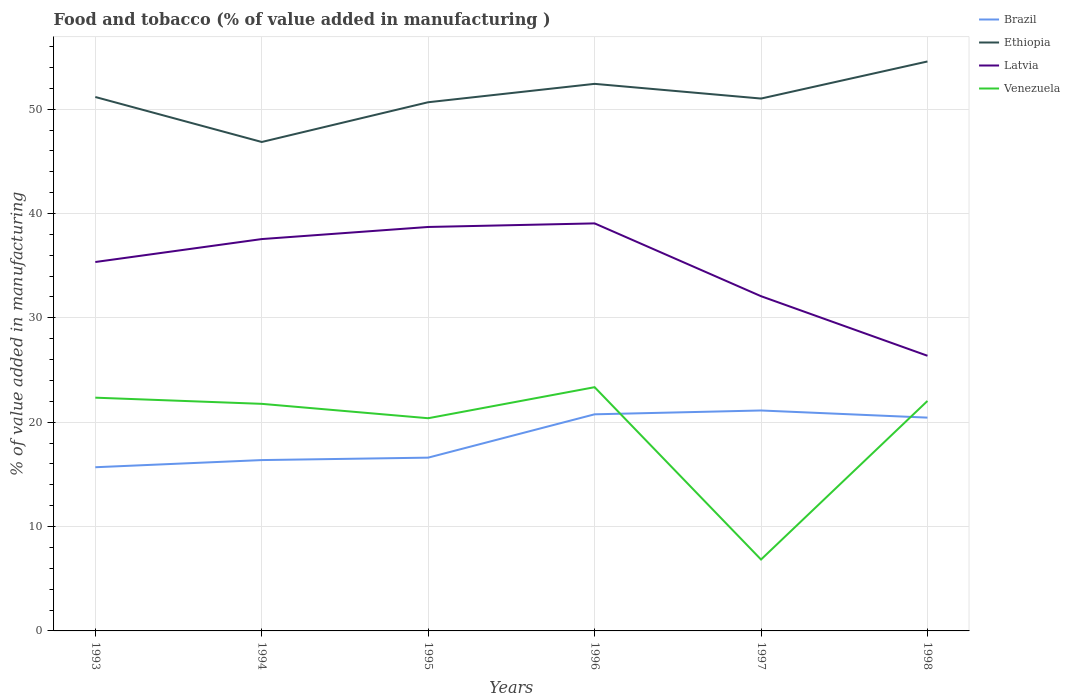How many different coloured lines are there?
Offer a terse response. 4. Does the line corresponding to Venezuela intersect with the line corresponding to Ethiopia?
Make the answer very short. No. Across all years, what is the maximum value added in manufacturing food and tobacco in Venezuela?
Give a very brief answer. 6.84. In which year was the value added in manufacturing food and tobacco in Ethiopia maximum?
Offer a terse response. 1994. What is the total value added in manufacturing food and tobacco in Latvia in the graph?
Ensure brevity in your answer.  12.34. What is the difference between the highest and the second highest value added in manufacturing food and tobacco in Ethiopia?
Your response must be concise. 7.71. What is the difference between two consecutive major ticks on the Y-axis?
Provide a short and direct response. 10. Does the graph contain any zero values?
Ensure brevity in your answer.  No. Where does the legend appear in the graph?
Offer a very short reply. Top right. What is the title of the graph?
Offer a terse response. Food and tobacco (% of value added in manufacturing ). Does "Panama" appear as one of the legend labels in the graph?
Provide a succinct answer. No. What is the label or title of the X-axis?
Keep it short and to the point. Years. What is the label or title of the Y-axis?
Offer a very short reply. % of value added in manufacturing. What is the % of value added in manufacturing in Brazil in 1993?
Offer a terse response. 15.69. What is the % of value added in manufacturing of Ethiopia in 1993?
Offer a terse response. 51.16. What is the % of value added in manufacturing in Latvia in 1993?
Your answer should be compact. 35.35. What is the % of value added in manufacturing of Venezuela in 1993?
Your response must be concise. 22.35. What is the % of value added in manufacturing of Brazil in 1994?
Your answer should be compact. 16.37. What is the % of value added in manufacturing of Ethiopia in 1994?
Offer a very short reply. 46.85. What is the % of value added in manufacturing of Latvia in 1994?
Offer a very short reply. 37.55. What is the % of value added in manufacturing of Venezuela in 1994?
Provide a succinct answer. 21.76. What is the % of value added in manufacturing in Brazil in 1995?
Ensure brevity in your answer.  16.6. What is the % of value added in manufacturing in Ethiopia in 1995?
Provide a succinct answer. 50.66. What is the % of value added in manufacturing of Latvia in 1995?
Give a very brief answer. 38.71. What is the % of value added in manufacturing of Venezuela in 1995?
Give a very brief answer. 20.38. What is the % of value added in manufacturing in Brazil in 1996?
Make the answer very short. 20.76. What is the % of value added in manufacturing in Ethiopia in 1996?
Provide a short and direct response. 52.42. What is the % of value added in manufacturing of Latvia in 1996?
Your response must be concise. 39.05. What is the % of value added in manufacturing in Venezuela in 1996?
Give a very brief answer. 23.36. What is the % of value added in manufacturing of Brazil in 1997?
Make the answer very short. 21.12. What is the % of value added in manufacturing in Ethiopia in 1997?
Provide a short and direct response. 51.01. What is the % of value added in manufacturing in Latvia in 1997?
Give a very brief answer. 32.08. What is the % of value added in manufacturing of Venezuela in 1997?
Give a very brief answer. 6.84. What is the % of value added in manufacturing of Brazil in 1998?
Your response must be concise. 20.44. What is the % of value added in manufacturing in Ethiopia in 1998?
Make the answer very short. 54.57. What is the % of value added in manufacturing of Latvia in 1998?
Make the answer very short. 26.37. What is the % of value added in manufacturing in Venezuela in 1998?
Offer a very short reply. 22.04. Across all years, what is the maximum % of value added in manufacturing of Brazil?
Give a very brief answer. 21.12. Across all years, what is the maximum % of value added in manufacturing in Ethiopia?
Make the answer very short. 54.57. Across all years, what is the maximum % of value added in manufacturing in Latvia?
Offer a very short reply. 39.05. Across all years, what is the maximum % of value added in manufacturing in Venezuela?
Provide a succinct answer. 23.36. Across all years, what is the minimum % of value added in manufacturing in Brazil?
Keep it short and to the point. 15.69. Across all years, what is the minimum % of value added in manufacturing in Ethiopia?
Keep it short and to the point. 46.85. Across all years, what is the minimum % of value added in manufacturing in Latvia?
Offer a very short reply. 26.37. Across all years, what is the minimum % of value added in manufacturing of Venezuela?
Ensure brevity in your answer.  6.84. What is the total % of value added in manufacturing of Brazil in the graph?
Your answer should be very brief. 110.98. What is the total % of value added in manufacturing in Ethiopia in the graph?
Keep it short and to the point. 306.68. What is the total % of value added in manufacturing of Latvia in the graph?
Provide a short and direct response. 209.1. What is the total % of value added in manufacturing in Venezuela in the graph?
Provide a short and direct response. 116.72. What is the difference between the % of value added in manufacturing of Brazil in 1993 and that in 1994?
Offer a terse response. -0.69. What is the difference between the % of value added in manufacturing of Ethiopia in 1993 and that in 1994?
Provide a succinct answer. 4.31. What is the difference between the % of value added in manufacturing in Latvia in 1993 and that in 1994?
Your answer should be compact. -2.2. What is the difference between the % of value added in manufacturing of Venezuela in 1993 and that in 1994?
Provide a short and direct response. 0.59. What is the difference between the % of value added in manufacturing in Brazil in 1993 and that in 1995?
Provide a succinct answer. -0.92. What is the difference between the % of value added in manufacturing of Ethiopia in 1993 and that in 1995?
Provide a succinct answer. 0.5. What is the difference between the % of value added in manufacturing of Latvia in 1993 and that in 1995?
Offer a very short reply. -3.36. What is the difference between the % of value added in manufacturing in Venezuela in 1993 and that in 1995?
Keep it short and to the point. 1.97. What is the difference between the % of value added in manufacturing in Brazil in 1993 and that in 1996?
Your answer should be very brief. -5.07. What is the difference between the % of value added in manufacturing of Ethiopia in 1993 and that in 1996?
Offer a very short reply. -1.26. What is the difference between the % of value added in manufacturing of Latvia in 1993 and that in 1996?
Your answer should be compact. -3.7. What is the difference between the % of value added in manufacturing in Venezuela in 1993 and that in 1996?
Your answer should be very brief. -1.01. What is the difference between the % of value added in manufacturing in Brazil in 1993 and that in 1997?
Your response must be concise. -5.44. What is the difference between the % of value added in manufacturing in Ethiopia in 1993 and that in 1997?
Offer a very short reply. 0.15. What is the difference between the % of value added in manufacturing of Latvia in 1993 and that in 1997?
Keep it short and to the point. 3.28. What is the difference between the % of value added in manufacturing of Venezuela in 1993 and that in 1997?
Offer a very short reply. 15.51. What is the difference between the % of value added in manufacturing in Brazil in 1993 and that in 1998?
Provide a succinct answer. -4.75. What is the difference between the % of value added in manufacturing of Ethiopia in 1993 and that in 1998?
Your answer should be very brief. -3.4. What is the difference between the % of value added in manufacturing of Latvia in 1993 and that in 1998?
Your response must be concise. 8.98. What is the difference between the % of value added in manufacturing of Venezuela in 1993 and that in 1998?
Your response must be concise. 0.31. What is the difference between the % of value added in manufacturing of Brazil in 1994 and that in 1995?
Offer a terse response. -0.23. What is the difference between the % of value added in manufacturing of Ethiopia in 1994 and that in 1995?
Your answer should be compact. -3.81. What is the difference between the % of value added in manufacturing in Latvia in 1994 and that in 1995?
Ensure brevity in your answer.  -1.16. What is the difference between the % of value added in manufacturing of Venezuela in 1994 and that in 1995?
Ensure brevity in your answer.  1.38. What is the difference between the % of value added in manufacturing of Brazil in 1994 and that in 1996?
Your response must be concise. -4.39. What is the difference between the % of value added in manufacturing in Ethiopia in 1994 and that in 1996?
Offer a terse response. -5.57. What is the difference between the % of value added in manufacturing of Latvia in 1994 and that in 1996?
Offer a terse response. -1.5. What is the difference between the % of value added in manufacturing of Venezuela in 1994 and that in 1996?
Make the answer very short. -1.6. What is the difference between the % of value added in manufacturing of Brazil in 1994 and that in 1997?
Give a very brief answer. -4.75. What is the difference between the % of value added in manufacturing in Ethiopia in 1994 and that in 1997?
Make the answer very short. -4.16. What is the difference between the % of value added in manufacturing of Latvia in 1994 and that in 1997?
Offer a very short reply. 5.47. What is the difference between the % of value added in manufacturing of Venezuela in 1994 and that in 1997?
Keep it short and to the point. 14.92. What is the difference between the % of value added in manufacturing of Brazil in 1994 and that in 1998?
Ensure brevity in your answer.  -4.07. What is the difference between the % of value added in manufacturing of Ethiopia in 1994 and that in 1998?
Keep it short and to the point. -7.71. What is the difference between the % of value added in manufacturing in Latvia in 1994 and that in 1998?
Offer a terse response. 11.18. What is the difference between the % of value added in manufacturing of Venezuela in 1994 and that in 1998?
Ensure brevity in your answer.  -0.28. What is the difference between the % of value added in manufacturing of Brazil in 1995 and that in 1996?
Provide a short and direct response. -4.15. What is the difference between the % of value added in manufacturing of Ethiopia in 1995 and that in 1996?
Your response must be concise. -1.76. What is the difference between the % of value added in manufacturing of Latvia in 1995 and that in 1996?
Provide a succinct answer. -0.34. What is the difference between the % of value added in manufacturing of Venezuela in 1995 and that in 1996?
Give a very brief answer. -2.98. What is the difference between the % of value added in manufacturing of Brazil in 1995 and that in 1997?
Give a very brief answer. -4.52. What is the difference between the % of value added in manufacturing in Ethiopia in 1995 and that in 1997?
Your answer should be compact. -0.35. What is the difference between the % of value added in manufacturing of Latvia in 1995 and that in 1997?
Your answer should be very brief. 6.63. What is the difference between the % of value added in manufacturing in Venezuela in 1995 and that in 1997?
Your response must be concise. 13.54. What is the difference between the % of value added in manufacturing of Brazil in 1995 and that in 1998?
Ensure brevity in your answer.  -3.83. What is the difference between the % of value added in manufacturing of Ethiopia in 1995 and that in 1998?
Make the answer very short. -3.91. What is the difference between the % of value added in manufacturing in Latvia in 1995 and that in 1998?
Offer a terse response. 12.34. What is the difference between the % of value added in manufacturing of Venezuela in 1995 and that in 1998?
Your answer should be very brief. -1.66. What is the difference between the % of value added in manufacturing of Brazil in 1996 and that in 1997?
Ensure brevity in your answer.  -0.37. What is the difference between the % of value added in manufacturing in Ethiopia in 1996 and that in 1997?
Ensure brevity in your answer.  1.41. What is the difference between the % of value added in manufacturing in Latvia in 1996 and that in 1997?
Keep it short and to the point. 6.98. What is the difference between the % of value added in manufacturing of Venezuela in 1996 and that in 1997?
Provide a succinct answer. 16.51. What is the difference between the % of value added in manufacturing in Brazil in 1996 and that in 1998?
Keep it short and to the point. 0.32. What is the difference between the % of value added in manufacturing in Ethiopia in 1996 and that in 1998?
Your answer should be very brief. -2.14. What is the difference between the % of value added in manufacturing of Latvia in 1996 and that in 1998?
Ensure brevity in your answer.  12.68. What is the difference between the % of value added in manufacturing in Venezuela in 1996 and that in 1998?
Ensure brevity in your answer.  1.32. What is the difference between the % of value added in manufacturing of Brazil in 1997 and that in 1998?
Provide a succinct answer. 0.68. What is the difference between the % of value added in manufacturing of Ethiopia in 1997 and that in 1998?
Your response must be concise. -3.55. What is the difference between the % of value added in manufacturing of Latvia in 1997 and that in 1998?
Offer a terse response. 5.71. What is the difference between the % of value added in manufacturing of Venezuela in 1997 and that in 1998?
Make the answer very short. -15.2. What is the difference between the % of value added in manufacturing of Brazil in 1993 and the % of value added in manufacturing of Ethiopia in 1994?
Your answer should be compact. -31.17. What is the difference between the % of value added in manufacturing in Brazil in 1993 and the % of value added in manufacturing in Latvia in 1994?
Ensure brevity in your answer.  -21.86. What is the difference between the % of value added in manufacturing in Brazil in 1993 and the % of value added in manufacturing in Venezuela in 1994?
Ensure brevity in your answer.  -6.07. What is the difference between the % of value added in manufacturing in Ethiopia in 1993 and the % of value added in manufacturing in Latvia in 1994?
Provide a succinct answer. 13.61. What is the difference between the % of value added in manufacturing in Ethiopia in 1993 and the % of value added in manufacturing in Venezuela in 1994?
Provide a succinct answer. 29.4. What is the difference between the % of value added in manufacturing in Latvia in 1993 and the % of value added in manufacturing in Venezuela in 1994?
Offer a very short reply. 13.59. What is the difference between the % of value added in manufacturing of Brazil in 1993 and the % of value added in manufacturing of Ethiopia in 1995?
Offer a terse response. -34.98. What is the difference between the % of value added in manufacturing of Brazil in 1993 and the % of value added in manufacturing of Latvia in 1995?
Provide a short and direct response. -23.02. What is the difference between the % of value added in manufacturing of Brazil in 1993 and the % of value added in manufacturing of Venezuela in 1995?
Make the answer very short. -4.7. What is the difference between the % of value added in manufacturing in Ethiopia in 1993 and the % of value added in manufacturing in Latvia in 1995?
Provide a succinct answer. 12.46. What is the difference between the % of value added in manufacturing in Ethiopia in 1993 and the % of value added in manufacturing in Venezuela in 1995?
Keep it short and to the point. 30.78. What is the difference between the % of value added in manufacturing of Latvia in 1993 and the % of value added in manufacturing of Venezuela in 1995?
Make the answer very short. 14.97. What is the difference between the % of value added in manufacturing of Brazil in 1993 and the % of value added in manufacturing of Ethiopia in 1996?
Make the answer very short. -36.74. What is the difference between the % of value added in manufacturing of Brazil in 1993 and the % of value added in manufacturing of Latvia in 1996?
Ensure brevity in your answer.  -23.37. What is the difference between the % of value added in manufacturing in Brazil in 1993 and the % of value added in manufacturing in Venezuela in 1996?
Your answer should be very brief. -7.67. What is the difference between the % of value added in manufacturing in Ethiopia in 1993 and the % of value added in manufacturing in Latvia in 1996?
Provide a succinct answer. 12.11. What is the difference between the % of value added in manufacturing in Ethiopia in 1993 and the % of value added in manufacturing in Venezuela in 1996?
Provide a succinct answer. 27.81. What is the difference between the % of value added in manufacturing of Latvia in 1993 and the % of value added in manufacturing of Venezuela in 1996?
Your answer should be very brief. 11.99. What is the difference between the % of value added in manufacturing of Brazil in 1993 and the % of value added in manufacturing of Ethiopia in 1997?
Provide a succinct answer. -35.33. What is the difference between the % of value added in manufacturing in Brazil in 1993 and the % of value added in manufacturing in Latvia in 1997?
Ensure brevity in your answer.  -16.39. What is the difference between the % of value added in manufacturing in Brazil in 1993 and the % of value added in manufacturing in Venezuela in 1997?
Provide a succinct answer. 8.84. What is the difference between the % of value added in manufacturing of Ethiopia in 1993 and the % of value added in manufacturing of Latvia in 1997?
Your answer should be compact. 19.09. What is the difference between the % of value added in manufacturing in Ethiopia in 1993 and the % of value added in manufacturing in Venezuela in 1997?
Provide a succinct answer. 44.32. What is the difference between the % of value added in manufacturing in Latvia in 1993 and the % of value added in manufacturing in Venezuela in 1997?
Give a very brief answer. 28.51. What is the difference between the % of value added in manufacturing of Brazil in 1993 and the % of value added in manufacturing of Ethiopia in 1998?
Offer a terse response. -38.88. What is the difference between the % of value added in manufacturing in Brazil in 1993 and the % of value added in manufacturing in Latvia in 1998?
Your answer should be very brief. -10.68. What is the difference between the % of value added in manufacturing in Brazil in 1993 and the % of value added in manufacturing in Venezuela in 1998?
Your answer should be very brief. -6.35. What is the difference between the % of value added in manufacturing in Ethiopia in 1993 and the % of value added in manufacturing in Latvia in 1998?
Your response must be concise. 24.8. What is the difference between the % of value added in manufacturing of Ethiopia in 1993 and the % of value added in manufacturing of Venezuela in 1998?
Keep it short and to the point. 29.13. What is the difference between the % of value added in manufacturing of Latvia in 1993 and the % of value added in manufacturing of Venezuela in 1998?
Keep it short and to the point. 13.31. What is the difference between the % of value added in manufacturing of Brazil in 1994 and the % of value added in manufacturing of Ethiopia in 1995?
Offer a very short reply. -34.29. What is the difference between the % of value added in manufacturing of Brazil in 1994 and the % of value added in manufacturing of Latvia in 1995?
Offer a very short reply. -22.34. What is the difference between the % of value added in manufacturing of Brazil in 1994 and the % of value added in manufacturing of Venezuela in 1995?
Provide a succinct answer. -4.01. What is the difference between the % of value added in manufacturing of Ethiopia in 1994 and the % of value added in manufacturing of Latvia in 1995?
Your response must be concise. 8.14. What is the difference between the % of value added in manufacturing in Ethiopia in 1994 and the % of value added in manufacturing in Venezuela in 1995?
Offer a very short reply. 26.47. What is the difference between the % of value added in manufacturing in Latvia in 1994 and the % of value added in manufacturing in Venezuela in 1995?
Make the answer very short. 17.17. What is the difference between the % of value added in manufacturing of Brazil in 1994 and the % of value added in manufacturing of Ethiopia in 1996?
Offer a very short reply. -36.05. What is the difference between the % of value added in manufacturing in Brazil in 1994 and the % of value added in manufacturing in Latvia in 1996?
Make the answer very short. -22.68. What is the difference between the % of value added in manufacturing of Brazil in 1994 and the % of value added in manufacturing of Venezuela in 1996?
Give a very brief answer. -6.99. What is the difference between the % of value added in manufacturing in Ethiopia in 1994 and the % of value added in manufacturing in Latvia in 1996?
Offer a terse response. 7.8. What is the difference between the % of value added in manufacturing in Ethiopia in 1994 and the % of value added in manufacturing in Venezuela in 1996?
Offer a very short reply. 23.5. What is the difference between the % of value added in manufacturing of Latvia in 1994 and the % of value added in manufacturing of Venezuela in 1996?
Your response must be concise. 14.19. What is the difference between the % of value added in manufacturing of Brazil in 1994 and the % of value added in manufacturing of Ethiopia in 1997?
Offer a terse response. -34.64. What is the difference between the % of value added in manufacturing in Brazil in 1994 and the % of value added in manufacturing in Latvia in 1997?
Give a very brief answer. -15.7. What is the difference between the % of value added in manufacturing of Brazil in 1994 and the % of value added in manufacturing of Venezuela in 1997?
Provide a short and direct response. 9.53. What is the difference between the % of value added in manufacturing in Ethiopia in 1994 and the % of value added in manufacturing in Latvia in 1997?
Make the answer very short. 14.78. What is the difference between the % of value added in manufacturing of Ethiopia in 1994 and the % of value added in manufacturing of Venezuela in 1997?
Your response must be concise. 40.01. What is the difference between the % of value added in manufacturing in Latvia in 1994 and the % of value added in manufacturing in Venezuela in 1997?
Provide a succinct answer. 30.71. What is the difference between the % of value added in manufacturing of Brazil in 1994 and the % of value added in manufacturing of Ethiopia in 1998?
Provide a succinct answer. -38.2. What is the difference between the % of value added in manufacturing of Brazil in 1994 and the % of value added in manufacturing of Latvia in 1998?
Your response must be concise. -10. What is the difference between the % of value added in manufacturing of Brazil in 1994 and the % of value added in manufacturing of Venezuela in 1998?
Your response must be concise. -5.67. What is the difference between the % of value added in manufacturing in Ethiopia in 1994 and the % of value added in manufacturing in Latvia in 1998?
Offer a very short reply. 20.48. What is the difference between the % of value added in manufacturing of Ethiopia in 1994 and the % of value added in manufacturing of Venezuela in 1998?
Provide a short and direct response. 24.82. What is the difference between the % of value added in manufacturing in Latvia in 1994 and the % of value added in manufacturing in Venezuela in 1998?
Offer a very short reply. 15.51. What is the difference between the % of value added in manufacturing in Brazil in 1995 and the % of value added in manufacturing in Ethiopia in 1996?
Ensure brevity in your answer.  -35.82. What is the difference between the % of value added in manufacturing of Brazil in 1995 and the % of value added in manufacturing of Latvia in 1996?
Your answer should be very brief. -22.45. What is the difference between the % of value added in manufacturing in Brazil in 1995 and the % of value added in manufacturing in Venezuela in 1996?
Make the answer very short. -6.75. What is the difference between the % of value added in manufacturing of Ethiopia in 1995 and the % of value added in manufacturing of Latvia in 1996?
Your answer should be compact. 11.61. What is the difference between the % of value added in manufacturing of Ethiopia in 1995 and the % of value added in manufacturing of Venezuela in 1996?
Offer a very short reply. 27.3. What is the difference between the % of value added in manufacturing in Latvia in 1995 and the % of value added in manufacturing in Venezuela in 1996?
Keep it short and to the point. 15.35. What is the difference between the % of value added in manufacturing of Brazil in 1995 and the % of value added in manufacturing of Ethiopia in 1997?
Give a very brief answer. -34.41. What is the difference between the % of value added in manufacturing of Brazil in 1995 and the % of value added in manufacturing of Latvia in 1997?
Give a very brief answer. -15.47. What is the difference between the % of value added in manufacturing in Brazil in 1995 and the % of value added in manufacturing in Venezuela in 1997?
Your response must be concise. 9.76. What is the difference between the % of value added in manufacturing of Ethiopia in 1995 and the % of value added in manufacturing of Latvia in 1997?
Make the answer very short. 18.59. What is the difference between the % of value added in manufacturing of Ethiopia in 1995 and the % of value added in manufacturing of Venezuela in 1997?
Make the answer very short. 43.82. What is the difference between the % of value added in manufacturing of Latvia in 1995 and the % of value added in manufacturing of Venezuela in 1997?
Ensure brevity in your answer.  31.87. What is the difference between the % of value added in manufacturing of Brazil in 1995 and the % of value added in manufacturing of Ethiopia in 1998?
Offer a terse response. -37.96. What is the difference between the % of value added in manufacturing of Brazil in 1995 and the % of value added in manufacturing of Latvia in 1998?
Your answer should be very brief. -9.76. What is the difference between the % of value added in manufacturing of Brazil in 1995 and the % of value added in manufacturing of Venezuela in 1998?
Offer a terse response. -5.43. What is the difference between the % of value added in manufacturing in Ethiopia in 1995 and the % of value added in manufacturing in Latvia in 1998?
Your answer should be compact. 24.29. What is the difference between the % of value added in manufacturing in Ethiopia in 1995 and the % of value added in manufacturing in Venezuela in 1998?
Provide a short and direct response. 28.62. What is the difference between the % of value added in manufacturing in Latvia in 1995 and the % of value added in manufacturing in Venezuela in 1998?
Ensure brevity in your answer.  16.67. What is the difference between the % of value added in manufacturing in Brazil in 1996 and the % of value added in manufacturing in Ethiopia in 1997?
Make the answer very short. -30.26. What is the difference between the % of value added in manufacturing of Brazil in 1996 and the % of value added in manufacturing of Latvia in 1997?
Give a very brief answer. -11.32. What is the difference between the % of value added in manufacturing in Brazil in 1996 and the % of value added in manufacturing in Venezuela in 1997?
Your answer should be compact. 13.91. What is the difference between the % of value added in manufacturing in Ethiopia in 1996 and the % of value added in manufacturing in Latvia in 1997?
Ensure brevity in your answer.  20.35. What is the difference between the % of value added in manufacturing in Ethiopia in 1996 and the % of value added in manufacturing in Venezuela in 1997?
Offer a terse response. 45.58. What is the difference between the % of value added in manufacturing in Latvia in 1996 and the % of value added in manufacturing in Venezuela in 1997?
Your answer should be very brief. 32.21. What is the difference between the % of value added in manufacturing in Brazil in 1996 and the % of value added in manufacturing in Ethiopia in 1998?
Ensure brevity in your answer.  -33.81. What is the difference between the % of value added in manufacturing of Brazil in 1996 and the % of value added in manufacturing of Latvia in 1998?
Ensure brevity in your answer.  -5.61. What is the difference between the % of value added in manufacturing in Brazil in 1996 and the % of value added in manufacturing in Venezuela in 1998?
Provide a succinct answer. -1.28. What is the difference between the % of value added in manufacturing in Ethiopia in 1996 and the % of value added in manufacturing in Latvia in 1998?
Your response must be concise. 26.05. What is the difference between the % of value added in manufacturing in Ethiopia in 1996 and the % of value added in manufacturing in Venezuela in 1998?
Keep it short and to the point. 30.39. What is the difference between the % of value added in manufacturing in Latvia in 1996 and the % of value added in manufacturing in Venezuela in 1998?
Provide a succinct answer. 17.02. What is the difference between the % of value added in manufacturing of Brazil in 1997 and the % of value added in manufacturing of Ethiopia in 1998?
Offer a very short reply. -33.44. What is the difference between the % of value added in manufacturing in Brazil in 1997 and the % of value added in manufacturing in Latvia in 1998?
Offer a very short reply. -5.25. What is the difference between the % of value added in manufacturing of Brazil in 1997 and the % of value added in manufacturing of Venezuela in 1998?
Keep it short and to the point. -0.91. What is the difference between the % of value added in manufacturing of Ethiopia in 1997 and the % of value added in manufacturing of Latvia in 1998?
Your answer should be very brief. 24.65. What is the difference between the % of value added in manufacturing of Ethiopia in 1997 and the % of value added in manufacturing of Venezuela in 1998?
Make the answer very short. 28.98. What is the difference between the % of value added in manufacturing in Latvia in 1997 and the % of value added in manufacturing in Venezuela in 1998?
Make the answer very short. 10.04. What is the average % of value added in manufacturing in Brazil per year?
Your response must be concise. 18.5. What is the average % of value added in manufacturing of Ethiopia per year?
Keep it short and to the point. 51.11. What is the average % of value added in manufacturing in Latvia per year?
Offer a terse response. 34.85. What is the average % of value added in manufacturing of Venezuela per year?
Your response must be concise. 19.45. In the year 1993, what is the difference between the % of value added in manufacturing in Brazil and % of value added in manufacturing in Ethiopia?
Make the answer very short. -35.48. In the year 1993, what is the difference between the % of value added in manufacturing in Brazil and % of value added in manufacturing in Latvia?
Provide a succinct answer. -19.66. In the year 1993, what is the difference between the % of value added in manufacturing of Brazil and % of value added in manufacturing of Venezuela?
Provide a short and direct response. -6.67. In the year 1993, what is the difference between the % of value added in manufacturing of Ethiopia and % of value added in manufacturing of Latvia?
Provide a succinct answer. 15.81. In the year 1993, what is the difference between the % of value added in manufacturing in Ethiopia and % of value added in manufacturing in Venezuela?
Offer a very short reply. 28.81. In the year 1993, what is the difference between the % of value added in manufacturing in Latvia and % of value added in manufacturing in Venezuela?
Make the answer very short. 13. In the year 1994, what is the difference between the % of value added in manufacturing in Brazil and % of value added in manufacturing in Ethiopia?
Your answer should be very brief. -30.48. In the year 1994, what is the difference between the % of value added in manufacturing of Brazil and % of value added in manufacturing of Latvia?
Offer a very short reply. -21.18. In the year 1994, what is the difference between the % of value added in manufacturing in Brazil and % of value added in manufacturing in Venezuela?
Ensure brevity in your answer.  -5.39. In the year 1994, what is the difference between the % of value added in manufacturing of Ethiopia and % of value added in manufacturing of Latvia?
Make the answer very short. 9.3. In the year 1994, what is the difference between the % of value added in manufacturing in Ethiopia and % of value added in manufacturing in Venezuela?
Your answer should be very brief. 25.09. In the year 1994, what is the difference between the % of value added in manufacturing of Latvia and % of value added in manufacturing of Venezuela?
Your answer should be compact. 15.79. In the year 1995, what is the difference between the % of value added in manufacturing in Brazil and % of value added in manufacturing in Ethiopia?
Your answer should be compact. -34.06. In the year 1995, what is the difference between the % of value added in manufacturing in Brazil and % of value added in manufacturing in Latvia?
Your answer should be very brief. -22.1. In the year 1995, what is the difference between the % of value added in manufacturing in Brazil and % of value added in manufacturing in Venezuela?
Offer a terse response. -3.78. In the year 1995, what is the difference between the % of value added in manufacturing in Ethiopia and % of value added in manufacturing in Latvia?
Your response must be concise. 11.95. In the year 1995, what is the difference between the % of value added in manufacturing of Ethiopia and % of value added in manufacturing of Venezuela?
Make the answer very short. 30.28. In the year 1995, what is the difference between the % of value added in manufacturing in Latvia and % of value added in manufacturing in Venezuela?
Your response must be concise. 18.33. In the year 1996, what is the difference between the % of value added in manufacturing of Brazil and % of value added in manufacturing of Ethiopia?
Provide a short and direct response. -31.67. In the year 1996, what is the difference between the % of value added in manufacturing in Brazil and % of value added in manufacturing in Latvia?
Provide a short and direct response. -18.3. In the year 1996, what is the difference between the % of value added in manufacturing of Brazil and % of value added in manufacturing of Venezuela?
Offer a terse response. -2.6. In the year 1996, what is the difference between the % of value added in manufacturing of Ethiopia and % of value added in manufacturing of Latvia?
Your answer should be very brief. 13.37. In the year 1996, what is the difference between the % of value added in manufacturing in Ethiopia and % of value added in manufacturing in Venezuela?
Provide a succinct answer. 29.07. In the year 1996, what is the difference between the % of value added in manufacturing in Latvia and % of value added in manufacturing in Venezuela?
Your answer should be compact. 15.7. In the year 1997, what is the difference between the % of value added in manufacturing in Brazil and % of value added in manufacturing in Ethiopia?
Your answer should be compact. -29.89. In the year 1997, what is the difference between the % of value added in manufacturing of Brazil and % of value added in manufacturing of Latvia?
Offer a terse response. -10.95. In the year 1997, what is the difference between the % of value added in manufacturing in Brazil and % of value added in manufacturing in Venezuela?
Your response must be concise. 14.28. In the year 1997, what is the difference between the % of value added in manufacturing in Ethiopia and % of value added in manufacturing in Latvia?
Ensure brevity in your answer.  18.94. In the year 1997, what is the difference between the % of value added in manufacturing in Ethiopia and % of value added in manufacturing in Venezuela?
Ensure brevity in your answer.  44.17. In the year 1997, what is the difference between the % of value added in manufacturing in Latvia and % of value added in manufacturing in Venezuela?
Provide a succinct answer. 25.23. In the year 1998, what is the difference between the % of value added in manufacturing in Brazil and % of value added in manufacturing in Ethiopia?
Your answer should be compact. -34.13. In the year 1998, what is the difference between the % of value added in manufacturing of Brazil and % of value added in manufacturing of Latvia?
Ensure brevity in your answer.  -5.93. In the year 1998, what is the difference between the % of value added in manufacturing in Brazil and % of value added in manufacturing in Venezuela?
Keep it short and to the point. -1.6. In the year 1998, what is the difference between the % of value added in manufacturing of Ethiopia and % of value added in manufacturing of Latvia?
Your answer should be compact. 28.2. In the year 1998, what is the difference between the % of value added in manufacturing in Ethiopia and % of value added in manufacturing in Venezuela?
Offer a very short reply. 32.53. In the year 1998, what is the difference between the % of value added in manufacturing in Latvia and % of value added in manufacturing in Venezuela?
Your answer should be very brief. 4.33. What is the ratio of the % of value added in manufacturing in Brazil in 1993 to that in 1994?
Make the answer very short. 0.96. What is the ratio of the % of value added in manufacturing of Ethiopia in 1993 to that in 1994?
Your answer should be compact. 1.09. What is the ratio of the % of value added in manufacturing of Latvia in 1993 to that in 1994?
Offer a very short reply. 0.94. What is the ratio of the % of value added in manufacturing of Venezuela in 1993 to that in 1994?
Provide a short and direct response. 1.03. What is the ratio of the % of value added in manufacturing of Brazil in 1993 to that in 1995?
Offer a terse response. 0.94. What is the ratio of the % of value added in manufacturing of Ethiopia in 1993 to that in 1995?
Make the answer very short. 1.01. What is the ratio of the % of value added in manufacturing of Latvia in 1993 to that in 1995?
Keep it short and to the point. 0.91. What is the ratio of the % of value added in manufacturing of Venezuela in 1993 to that in 1995?
Your response must be concise. 1.1. What is the ratio of the % of value added in manufacturing in Brazil in 1993 to that in 1996?
Make the answer very short. 0.76. What is the ratio of the % of value added in manufacturing of Ethiopia in 1993 to that in 1996?
Provide a short and direct response. 0.98. What is the ratio of the % of value added in manufacturing in Latvia in 1993 to that in 1996?
Provide a succinct answer. 0.91. What is the ratio of the % of value added in manufacturing of Venezuela in 1993 to that in 1996?
Give a very brief answer. 0.96. What is the ratio of the % of value added in manufacturing in Brazil in 1993 to that in 1997?
Keep it short and to the point. 0.74. What is the ratio of the % of value added in manufacturing of Latvia in 1993 to that in 1997?
Your answer should be compact. 1.1. What is the ratio of the % of value added in manufacturing of Venezuela in 1993 to that in 1997?
Make the answer very short. 3.27. What is the ratio of the % of value added in manufacturing in Brazil in 1993 to that in 1998?
Offer a very short reply. 0.77. What is the ratio of the % of value added in manufacturing in Ethiopia in 1993 to that in 1998?
Keep it short and to the point. 0.94. What is the ratio of the % of value added in manufacturing in Latvia in 1993 to that in 1998?
Make the answer very short. 1.34. What is the ratio of the % of value added in manufacturing in Venezuela in 1993 to that in 1998?
Your answer should be compact. 1.01. What is the ratio of the % of value added in manufacturing in Brazil in 1994 to that in 1995?
Offer a very short reply. 0.99. What is the ratio of the % of value added in manufacturing in Ethiopia in 1994 to that in 1995?
Provide a short and direct response. 0.92. What is the ratio of the % of value added in manufacturing of Venezuela in 1994 to that in 1995?
Provide a succinct answer. 1.07. What is the ratio of the % of value added in manufacturing in Brazil in 1994 to that in 1996?
Give a very brief answer. 0.79. What is the ratio of the % of value added in manufacturing in Ethiopia in 1994 to that in 1996?
Keep it short and to the point. 0.89. What is the ratio of the % of value added in manufacturing in Latvia in 1994 to that in 1996?
Give a very brief answer. 0.96. What is the ratio of the % of value added in manufacturing of Venezuela in 1994 to that in 1996?
Provide a short and direct response. 0.93. What is the ratio of the % of value added in manufacturing of Brazil in 1994 to that in 1997?
Keep it short and to the point. 0.78. What is the ratio of the % of value added in manufacturing of Ethiopia in 1994 to that in 1997?
Your answer should be compact. 0.92. What is the ratio of the % of value added in manufacturing of Latvia in 1994 to that in 1997?
Offer a very short reply. 1.17. What is the ratio of the % of value added in manufacturing in Venezuela in 1994 to that in 1997?
Keep it short and to the point. 3.18. What is the ratio of the % of value added in manufacturing in Brazil in 1994 to that in 1998?
Your answer should be very brief. 0.8. What is the ratio of the % of value added in manufacturing in Ethiopia in 1994 to that in 1998?
Your answer should be very brief. 0.86. What is the ratio of the % of value added in manufacturing in Latvia in 1994 to that in 1998?
Make the answer very short. 1.42. What is the ratio of the % of value added in manufacturing of Venezuela in 1994 to that in 1998?
Provide a succinct answer. 0.99. What is the ratio of the % of value added in manufacturing in Ethiopia in 1995 to that in 1996?
Give a very brief answer. 0.97. What is the ratio of the % of value added in manufacturing in Latvia in 1995 to that in 1996?
Keep it short and to the point. 0.99. What is the ratio of the % of value added in manufacturing of Venezuela in 1995 to that in 1996?
Your response must be concise. 0.87. What is the ratio of the % of value added in manufacturing of Brazil in 1995 to that in 1997?
Provide a short and direct response. 0.79. What is the ratio of the % of value added in manufacturing of Ethiopia in 1995 to that in 1997?
Offer a terse response. 0.99. What is the ratio of the % of value added in manufacturing in Latvia in 1995 to that in 1997?
Give a very brief answer. 1.21. What is the ratio of the % of value added in manufacturing in Venezuela in 1995 to that in 1997?
Your response must be concise. 2.98. What is the ratio of the % of value added in manufacturing in Brazil in 1995 to that in 1998?
Make the answer very short. 0.81. What is the ratio of the % of value added in manufacturing in Ethiopia in 1995 to that in 1998?
Keep it short and to the point. 0.93. What is the ratio of the % of value added in manufacturing of Latvia in 1995 to that in 1998?
Your response must be concise. 1.47. What is the ratio of the % of value added in manufacturing in Venezuela in 1995 to that in 1998?
Your response must be concise. 0.92. What is the ratio of the % of value added in manufacturing in Brazil in 1996 to that in 1997?
Provide a short and direct response. 0.98. What is the ratio of the % of value added in manufacturing of Ethiopia in 1996 to that in 1997?
Your response must be concise. 1.03. What is the ratio of the % of value added in manufacturing of Latvia in 1996 to that in 1997?
Provide a succinct answer. 1.22. What is the ratio of the % of value added in manufacturing in Venezuela in 1996 to that in 1997?
Your response must be concise. 3.41. What is the ratio of the % of value added in manufacturing of Brazil in 1996 to that in 1998?
Give a very brief answer. 1.02. What is the ratio of the % of value added in manufacturing of Ethiopia in 1996 to that in 1998?
Keep it short and to the point. 0.96. What is the ratio of the % of value added in manufacturing in Latvia in 1996 to that in 1998?
Make the answer very short. 1.48. What is the ratio of the % of value added in manufacturing in Venezuela in 1996 to that in 1998?
Your answer should be very brief. 1.06. What is the ratio of the % of value added in manufacturing of Brazil in 1997 to that in 1998?
Provide a succinct answer. 1.03. What is the ratio of the % of value added in manufacturing in Ethiopia in 1997 to that in 1998?
Provide a short and direct response. 0.93. What is the ratio of the % of value added in manufacturing of Latvia in 1997 to that in 1998?
Offer a terse response. 1.22. What is the ratio of the % of value added in manufacturing of Venezuela in 1997 to that in 1998?
Your answer should be very brief. 0.31. What is the difference between the highest and the second highest % of value added in manufacturing of Brazil?
Your answer should be very brief. 0.37. What is the difference between the highest and the second highest % of value added in manufacturing of Ethiopia?
Ensure brevity in your answer.  2.14. What is the difference between the highest and the second highest % of value added in manufacturing of Latvia?
Your response must be concise. 0.34. What is the difference between the highest and the second highest % of value added in manufacturing of Venezuela?
Keep it short and to the point. 1.01. What is the difference between the highest and the lowest % of value added in manufacturing of Brazil?
Your response must be concise. 5.44. What is the difference between the highest and the lowest % of value added in manufacturing of Ethiopia?
Provide a short and direct response. 7.71. What is the difference between the highest and the lowest % of value added in manufacturing in Latvia?
Make the answer very short. 12.68. What is the difference between the highest and the lowest % of value added in manufacturing of Venezuela?
Offer a terse response. 16.51. 